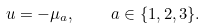<formula> <loc_0><loc_0><loc_500><loc_500>u = - \mu _ { a } , \quad a \in \{ 1 , 2 , 3 \} .</formula> 